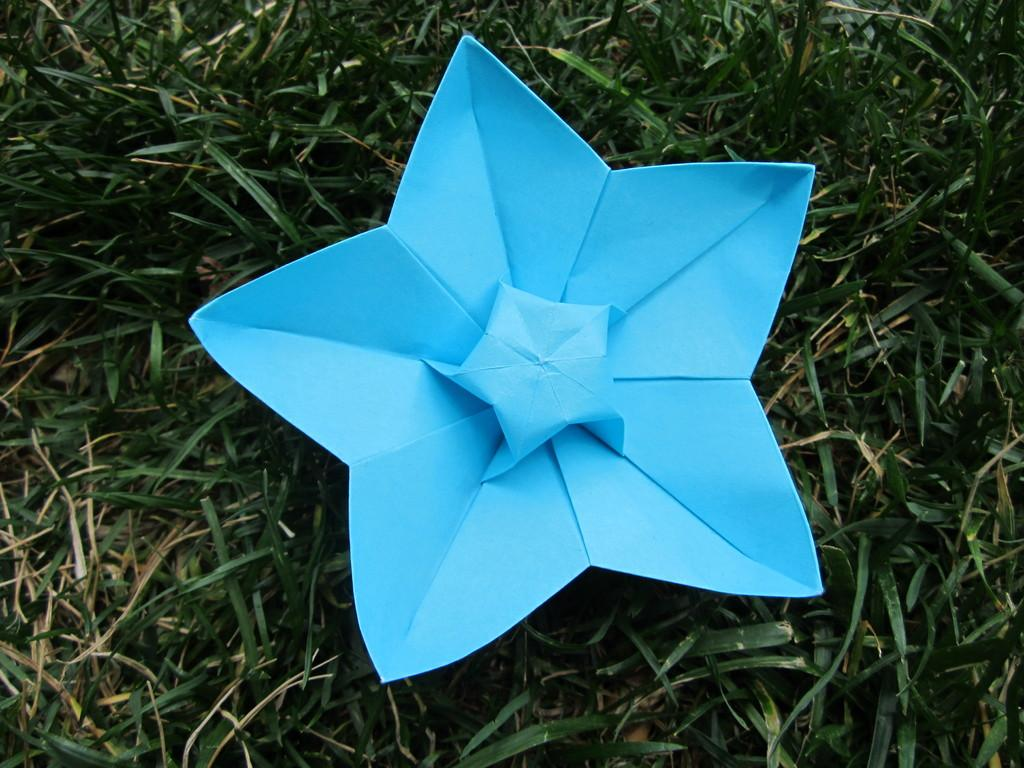What is the main subject of the image? The main subject of the image is a paper flower. Where is the paper flower located? The paper flower is on the grass. What type of oil is being used to water the paper flower in the image? There is no oil present in the image, and the paper flower does not require watering. 